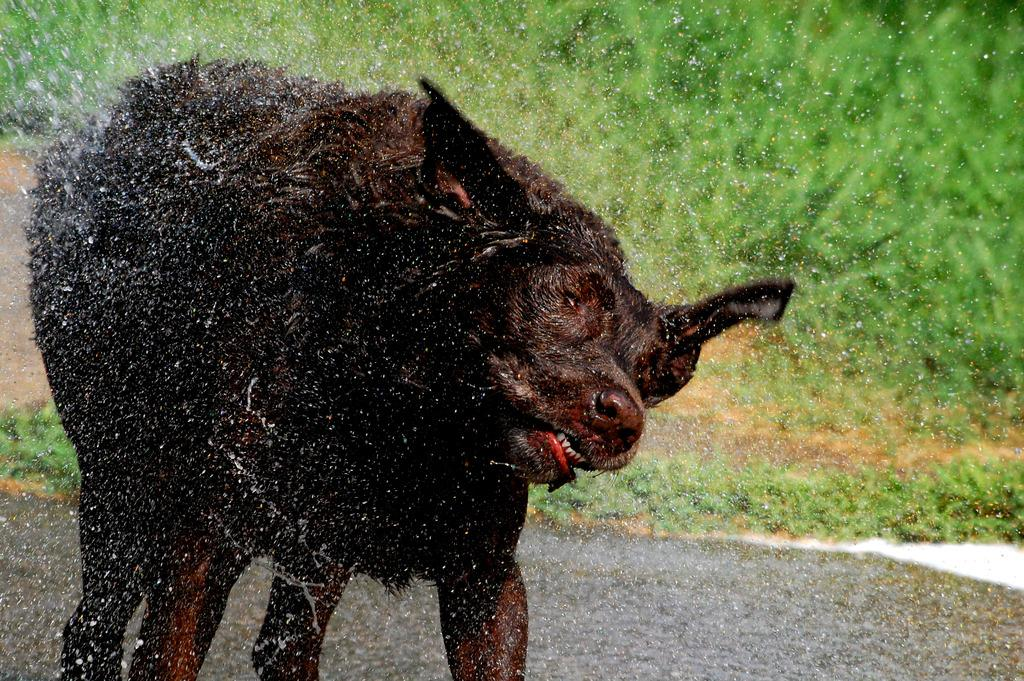What is the main feature of the image? There is a road in the image. What can be seen on the road? A black-colored dog is standing on the road. What else is visible in the image besides the road and the dog? There is water visible in the image. What type of vegetation is present in the background of the image? There is grass in the background of the image. Where is the throne located in the image? There is no throne present in the image. How many passengers are visible in the image? There are no passengers visible in the image. 